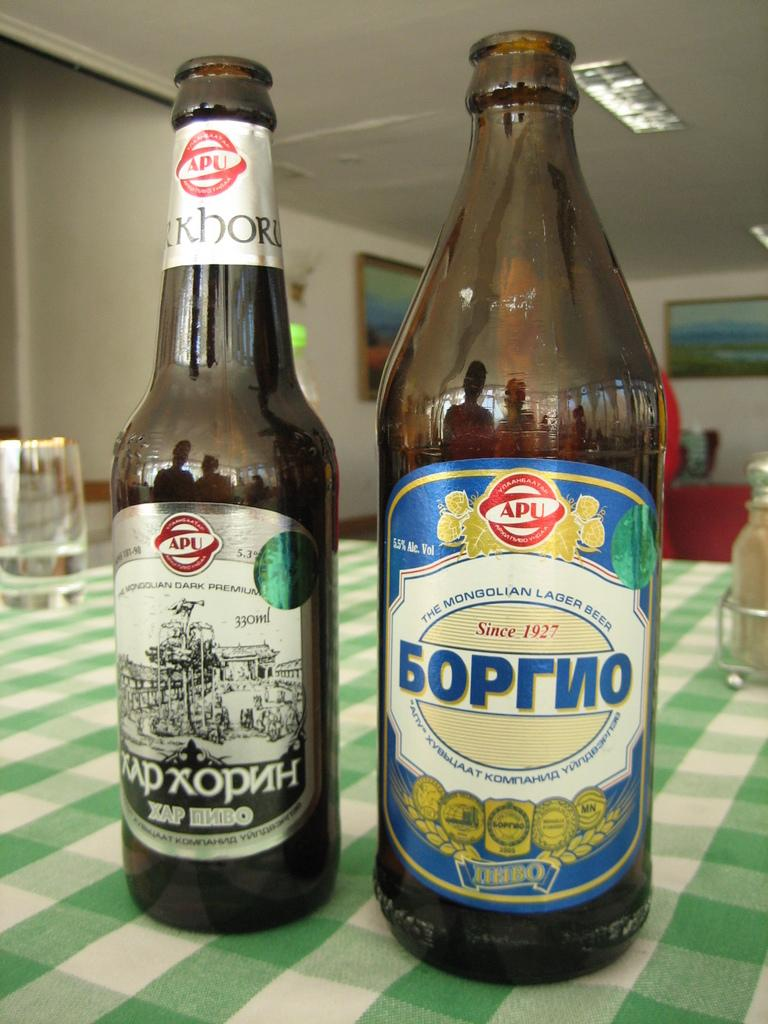<image>
Create a compact narrative representing the image presented. Two bottles on a table have the word APU on them. 